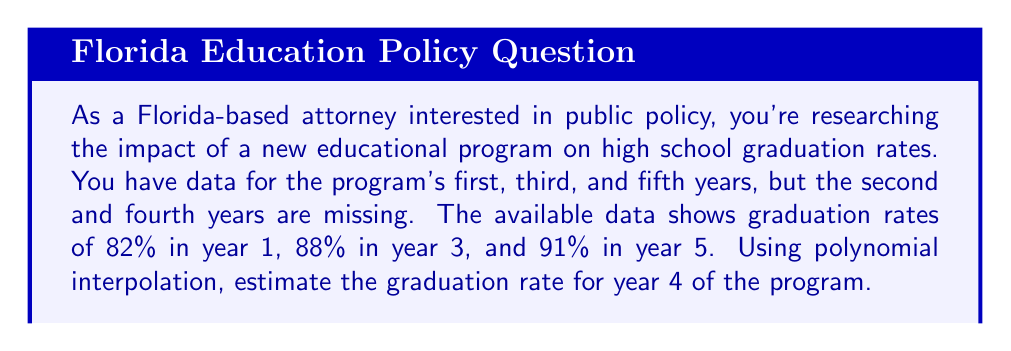Give your solution to this math problem. To solve this problem, we'll use Lagrange polynomial interpolation. The steps are as follows:

1) First, let's define our known points:
   $(x_1, y_1) = (1, 82)$, $(x_2, y_2) = (3, 88)$, $(x_3, y_3) = (5, 91)$

2) The Lagrange interpolation polynomial is given by:
   $$L(x) = y_1\frac{(x-x_2)(x-x_3)}{(x_1-x_2)(x_1-x_3)} + y_2\frac{(x-x_1)(x-x_3)}{(x_2-x_1)(x_2-x_3)} + y_3\frac{(x-x_1)(x-x_2)}{(x_3-x_1)(x_3-x_2)}$$

3) Substituting our known values:
   $$L(x) = 82\frac{(x-3)(x-5)}{(1-3)(1-5)} + 88\frac{(x-1)(x-5)}{(3-1)(3-5)} + 91\frac{(x-1)(x-3)}{(5-1)(5-3)}$$

4) Simplifying:
   $$L(x) = 82\frac{(x-3)(x-5)}{(-2)(-4)} + 88\frac{(x-1)(x-5)}{(2)(-2)} + 91\frac{(x-1)(x-3)}{(4)(2)}$$
   $$L(x) = 10.25(x-3)(x-5) - 22(x-1)(x-5) + 11.375(x-1)(x-3)$$

5) To find the graduation rate for year 4, we need to calculate $L(4)$:
   $$L(4) = 10.25(4-3)(4-5) - 22(4-1)(4-5) + 11.375(4-1)(4-3)$$
   $$= 10.25(1)(-1) - 22(3)(-1) + 11.375(3)(1)$$
   $$= -10.25 + 66 + 34.125$$
   $$= 89.875$$

6) Rounding to the nearest percentage point, we get 90%.
Answer: The estimated graduation rate for year 4 of the program is 90%. 